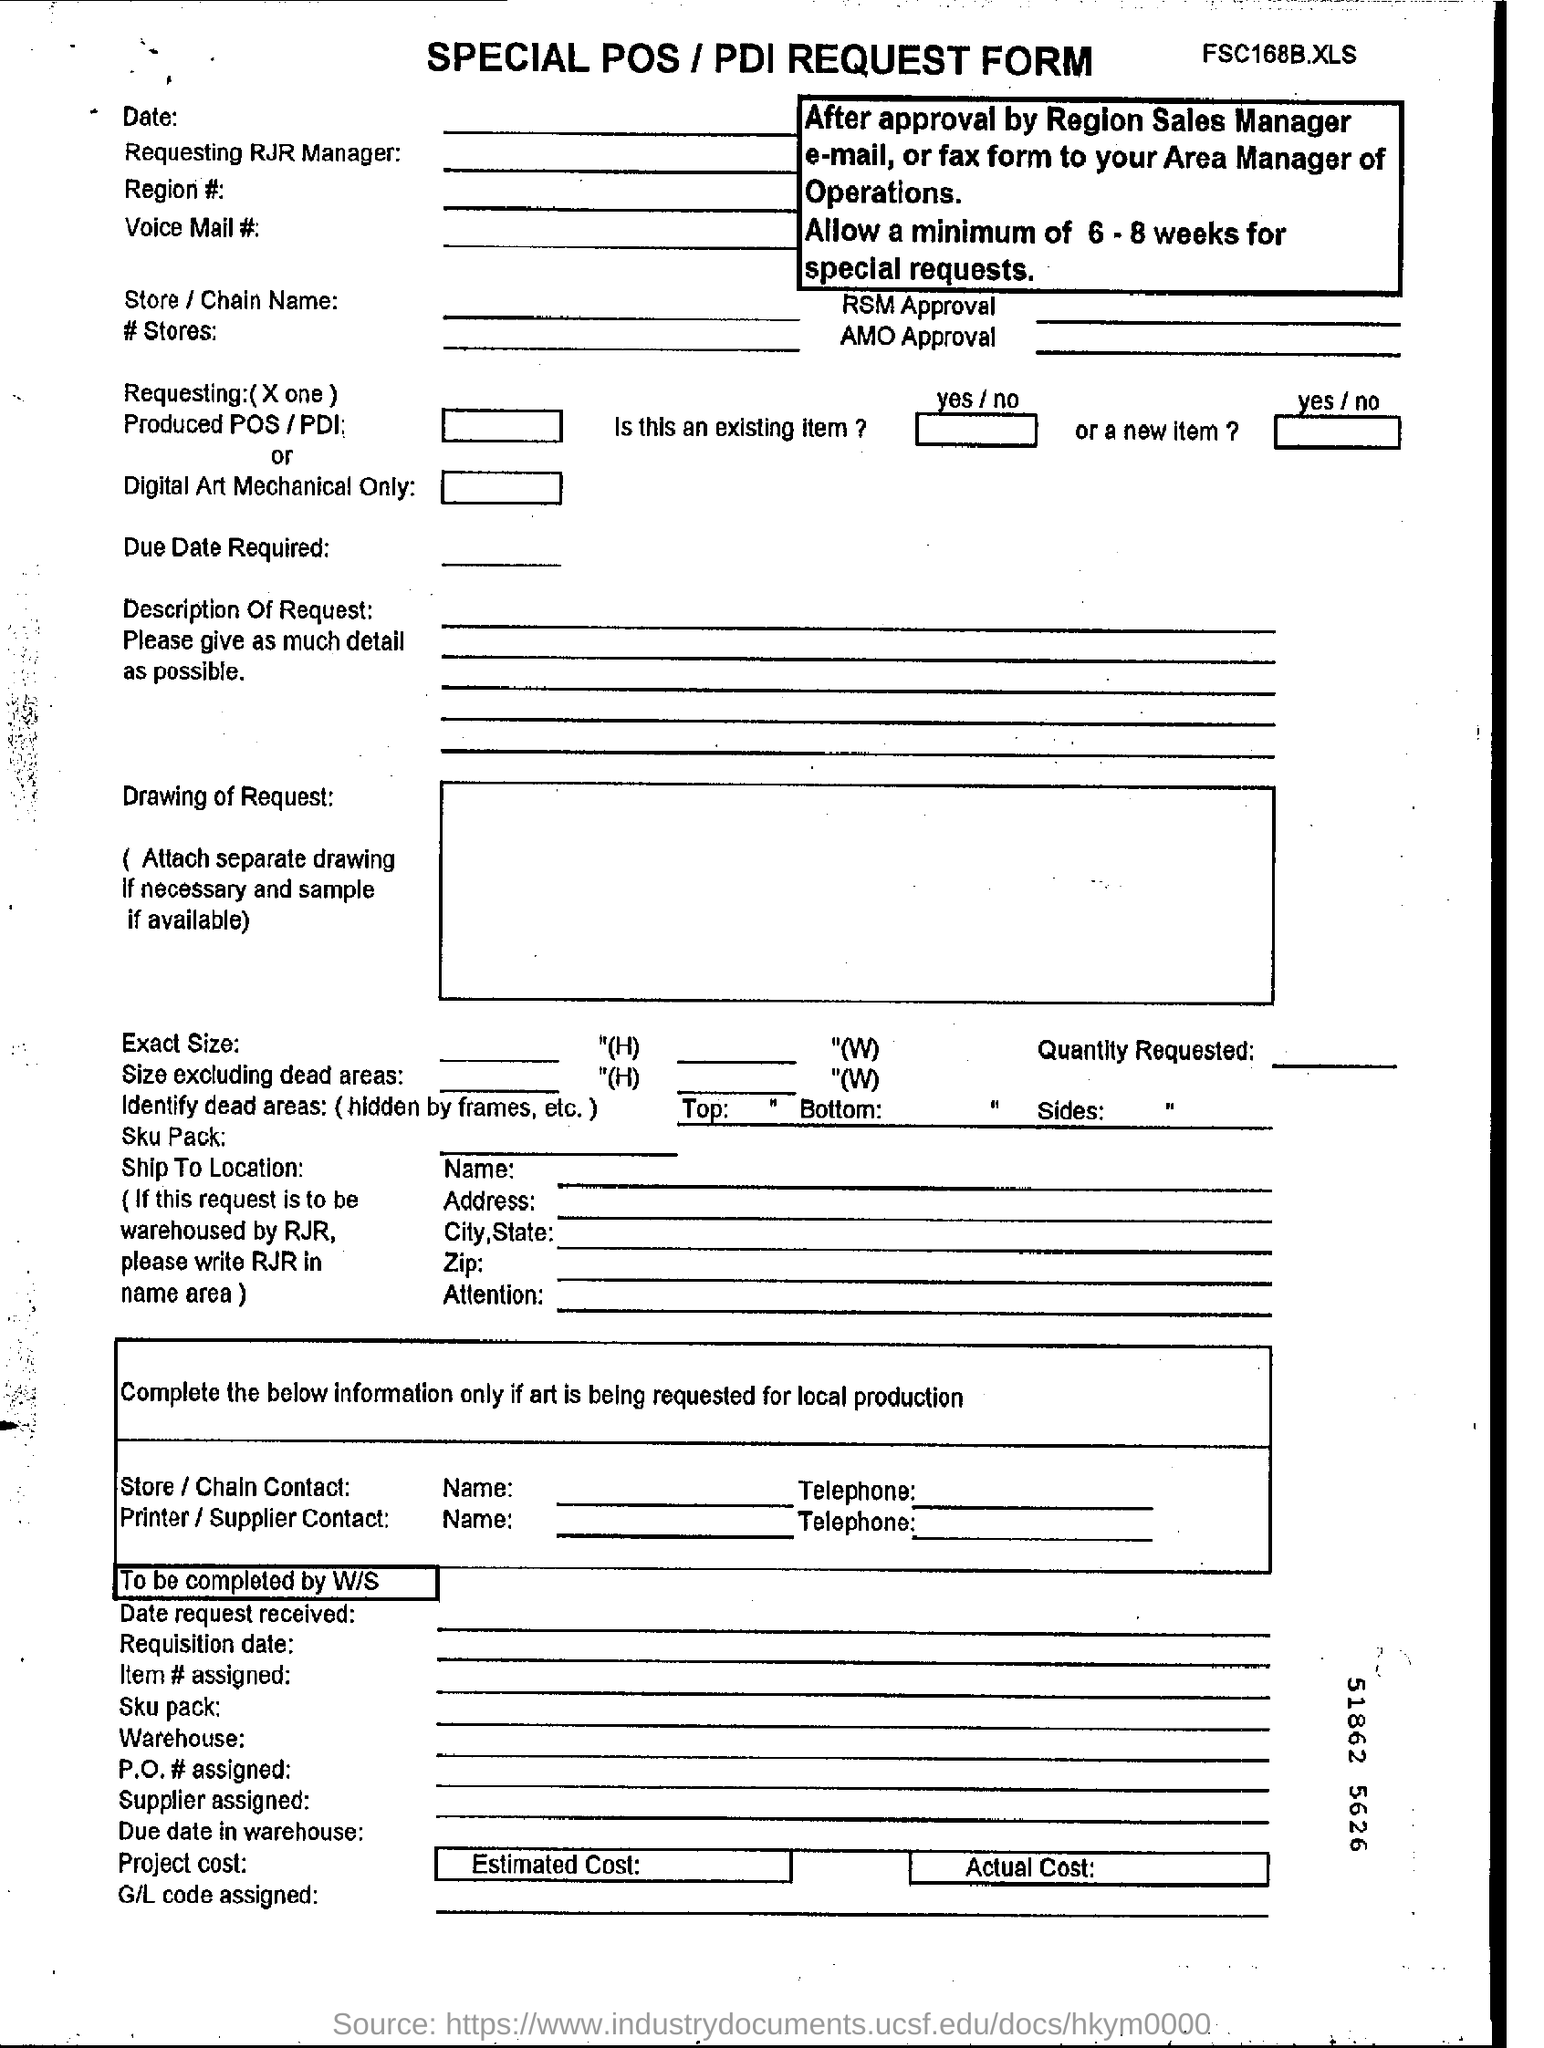What type of form is this?
Ensure brevity in your answer.  SPECIAL POS / PDI REQUEST FORM. What is the minimum time allowed for special requests?
Your response must be concise. Allow a minimum of 6-8 weeks for special requests. 